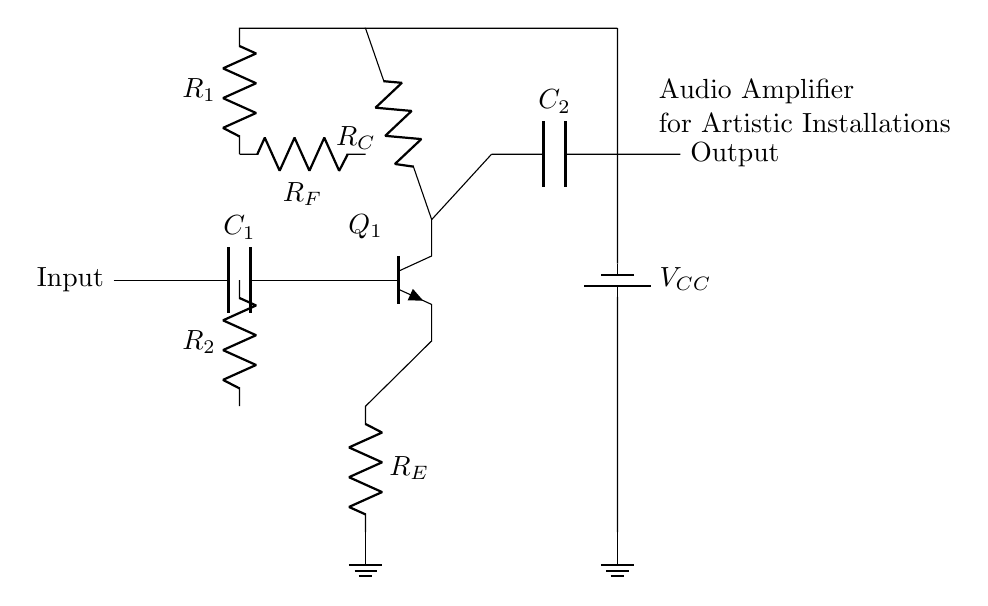What is the input of this circuit? The input is connected to a capacitor labeled C1, providing the audio signal to the rest of the amplifier circuit.
Answer: C1 What type of transistor is used in this circuit? The transistor indicated in the diagram is shown as an npn type, which is typically used for amplification in circuits, allowing current to flow from collector to emitter based on input current.
Answer: npn What does the feedback resistor R_F do? R_F creates a feedback loop from the output to the input, which stabilizes the amplifier's gain and improves linearity by feeding part of the output back to the input.
Answer: Stabilizes gain What is the purpose of R_E in this circuit? R_E serves as an emitter resistor, helping to set the operating point of the transistor and improve thermal stability by providing negative feedback.
Answer: Emitter resistor How many resistors are present in the circuit? The circuit has three resistors labeled R_E, R_C, and R_1, and R_2 which are essential for setting the biasing and feedback of the amplifier.
Answer: Four What is the role of the battery in the circuit? The battery labeled V_CC provides the necessary supply voltage for the transistor's operation, enabling it to amplify the input signal.
Answer: Power supply What is the overall function of this circuit? The circuit is designed to amplify audio signals to enhance sound quality, particularly in artistic installations, by increasing the audio signal's power.
Answer: Audio amplifier 